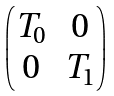Convert formula to latex. <formula><loc_0><loc_0><loc_500><loc_500>\begin{pmatrix} T _ { 0 } & 0 \\ 0 & T _ { 1 } \end{pmatrix}</formula> 